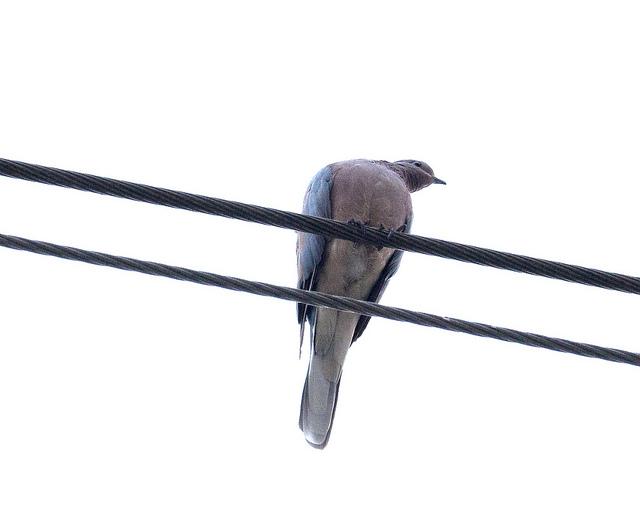What is the bird on?
Give a very brief answer. Wire. What color is its feet?
Quick response, please. Black. What type of bird is this?
Write a very short answer. Pigeon. Is the bird provoked by a predator?
Write a very short answer. No. What is this breed of bird called?
Concise answer only. Pigeon. 